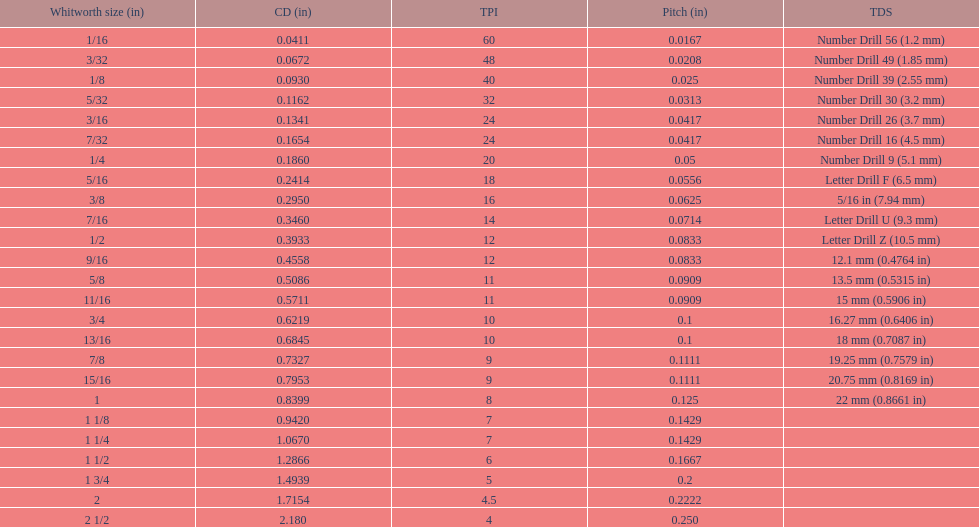What is the core diameter of the last whitworth thread size? 2.180. 